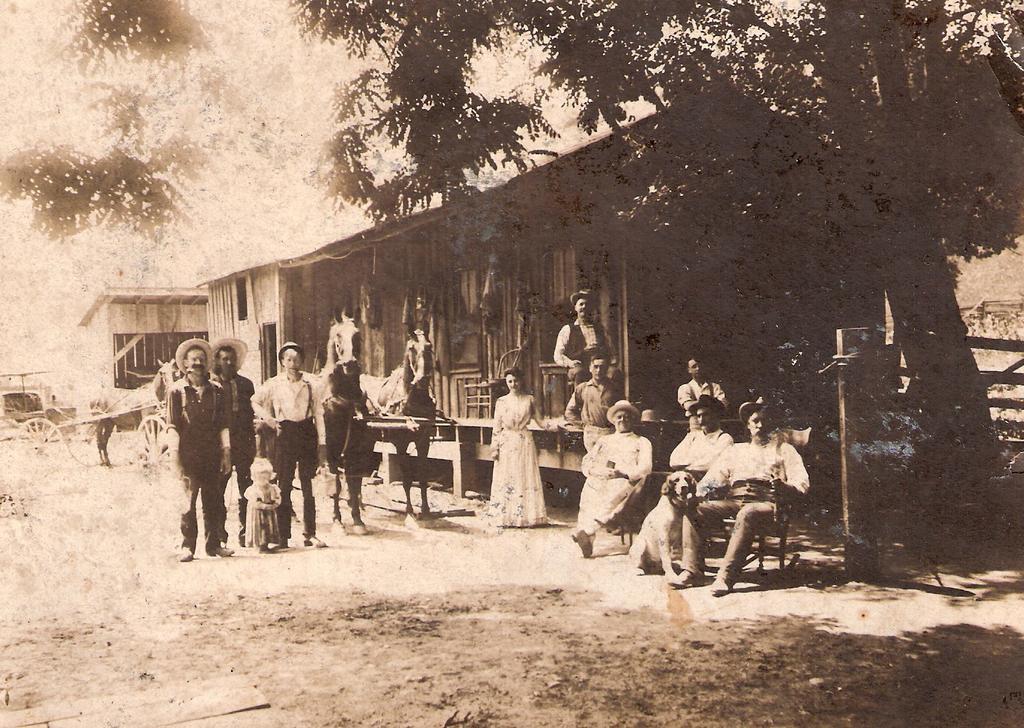Describe this image in one or two sentences. In this image it seems like a vintage photo where we can see there are few people standing on the ground, while some people are sitting on the chairs. In the middle there is a horse cart. On the right side there is a tree. Beside the tree there is a house. At the bottom there is sand. 